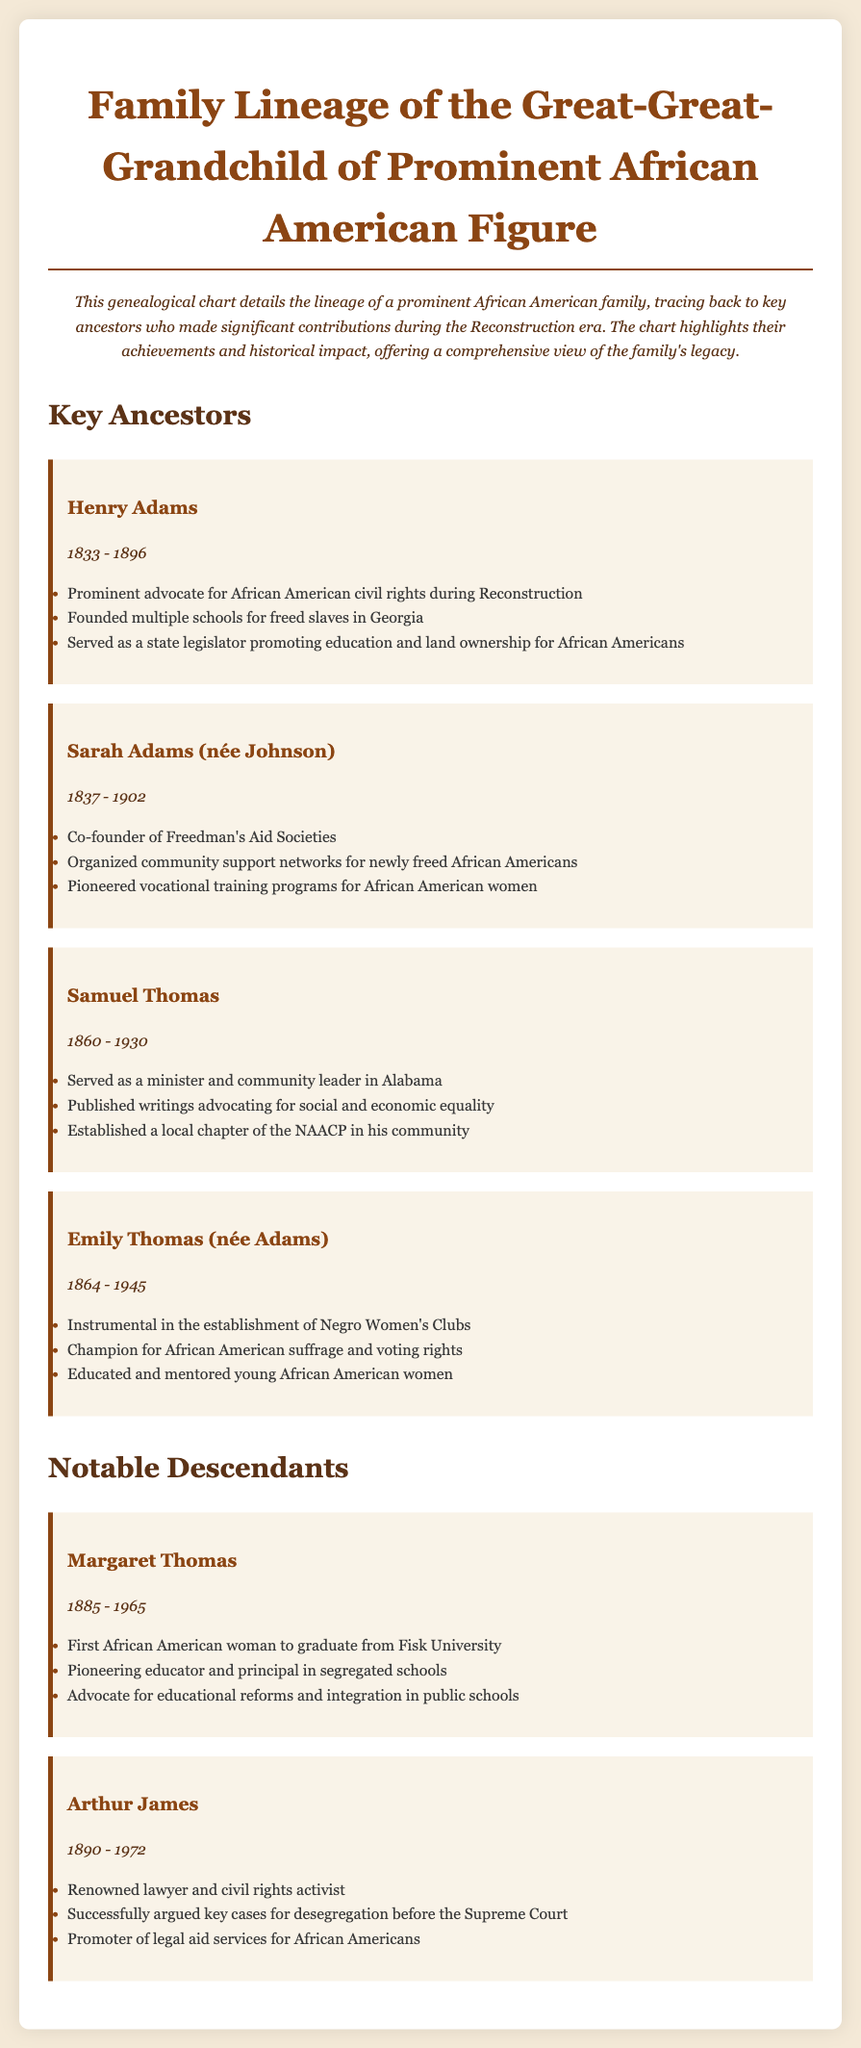What was Henry Adams' role during Reconstruction? Henry Adams was a prominent advocate for African American civil rights during Reconstruction, as stated in the document.
Answer: Advocate for civil rights What were the years of Sarah Adams' life? Sarah Adams lived from 1837 to 1902, which is directly mentioned in her section.
Answer: 1837 - 1902 Which ancestor founded schools for freed slaves? The document indicates that Henry Adams founded multiple schools for freed slaves in Georgia, highlighting his contribution.
Answer: Henry Adams What notable club did Emily Thomas help to establish? Emily Thomas was instrumental in the establishment of Negro Women's Clubs, according to the document.
Answer: Negro Women's Clubs Who was the first African American woman to graduate from Fisk University? The document lists Margaret Thomas as the first African American woman to graduate from Fisk University.
Answer: Margaret Thomas What significant action did Arthur James achieve in his career? Arthur James successfully argued key cases for desegregation before the Supreme Court, as noted in the text.
Answer: Desegregation cases How many key ancestors are detailed in the document? There are four key ancestors detailed in the document, according to the sections provided.
Answer: Four What pioneering educational role did Margaret Thomas hold? Margaret Thomas is described as a pioneering educator and principal in segregated schools in the document.
Answer: Educator and principal What contribution did Sarah Adams make to vocational training? Sarah Adams pioneered vocational training programs for African American women, as highlighted in her contributions.
Answer: Vocational training programs 